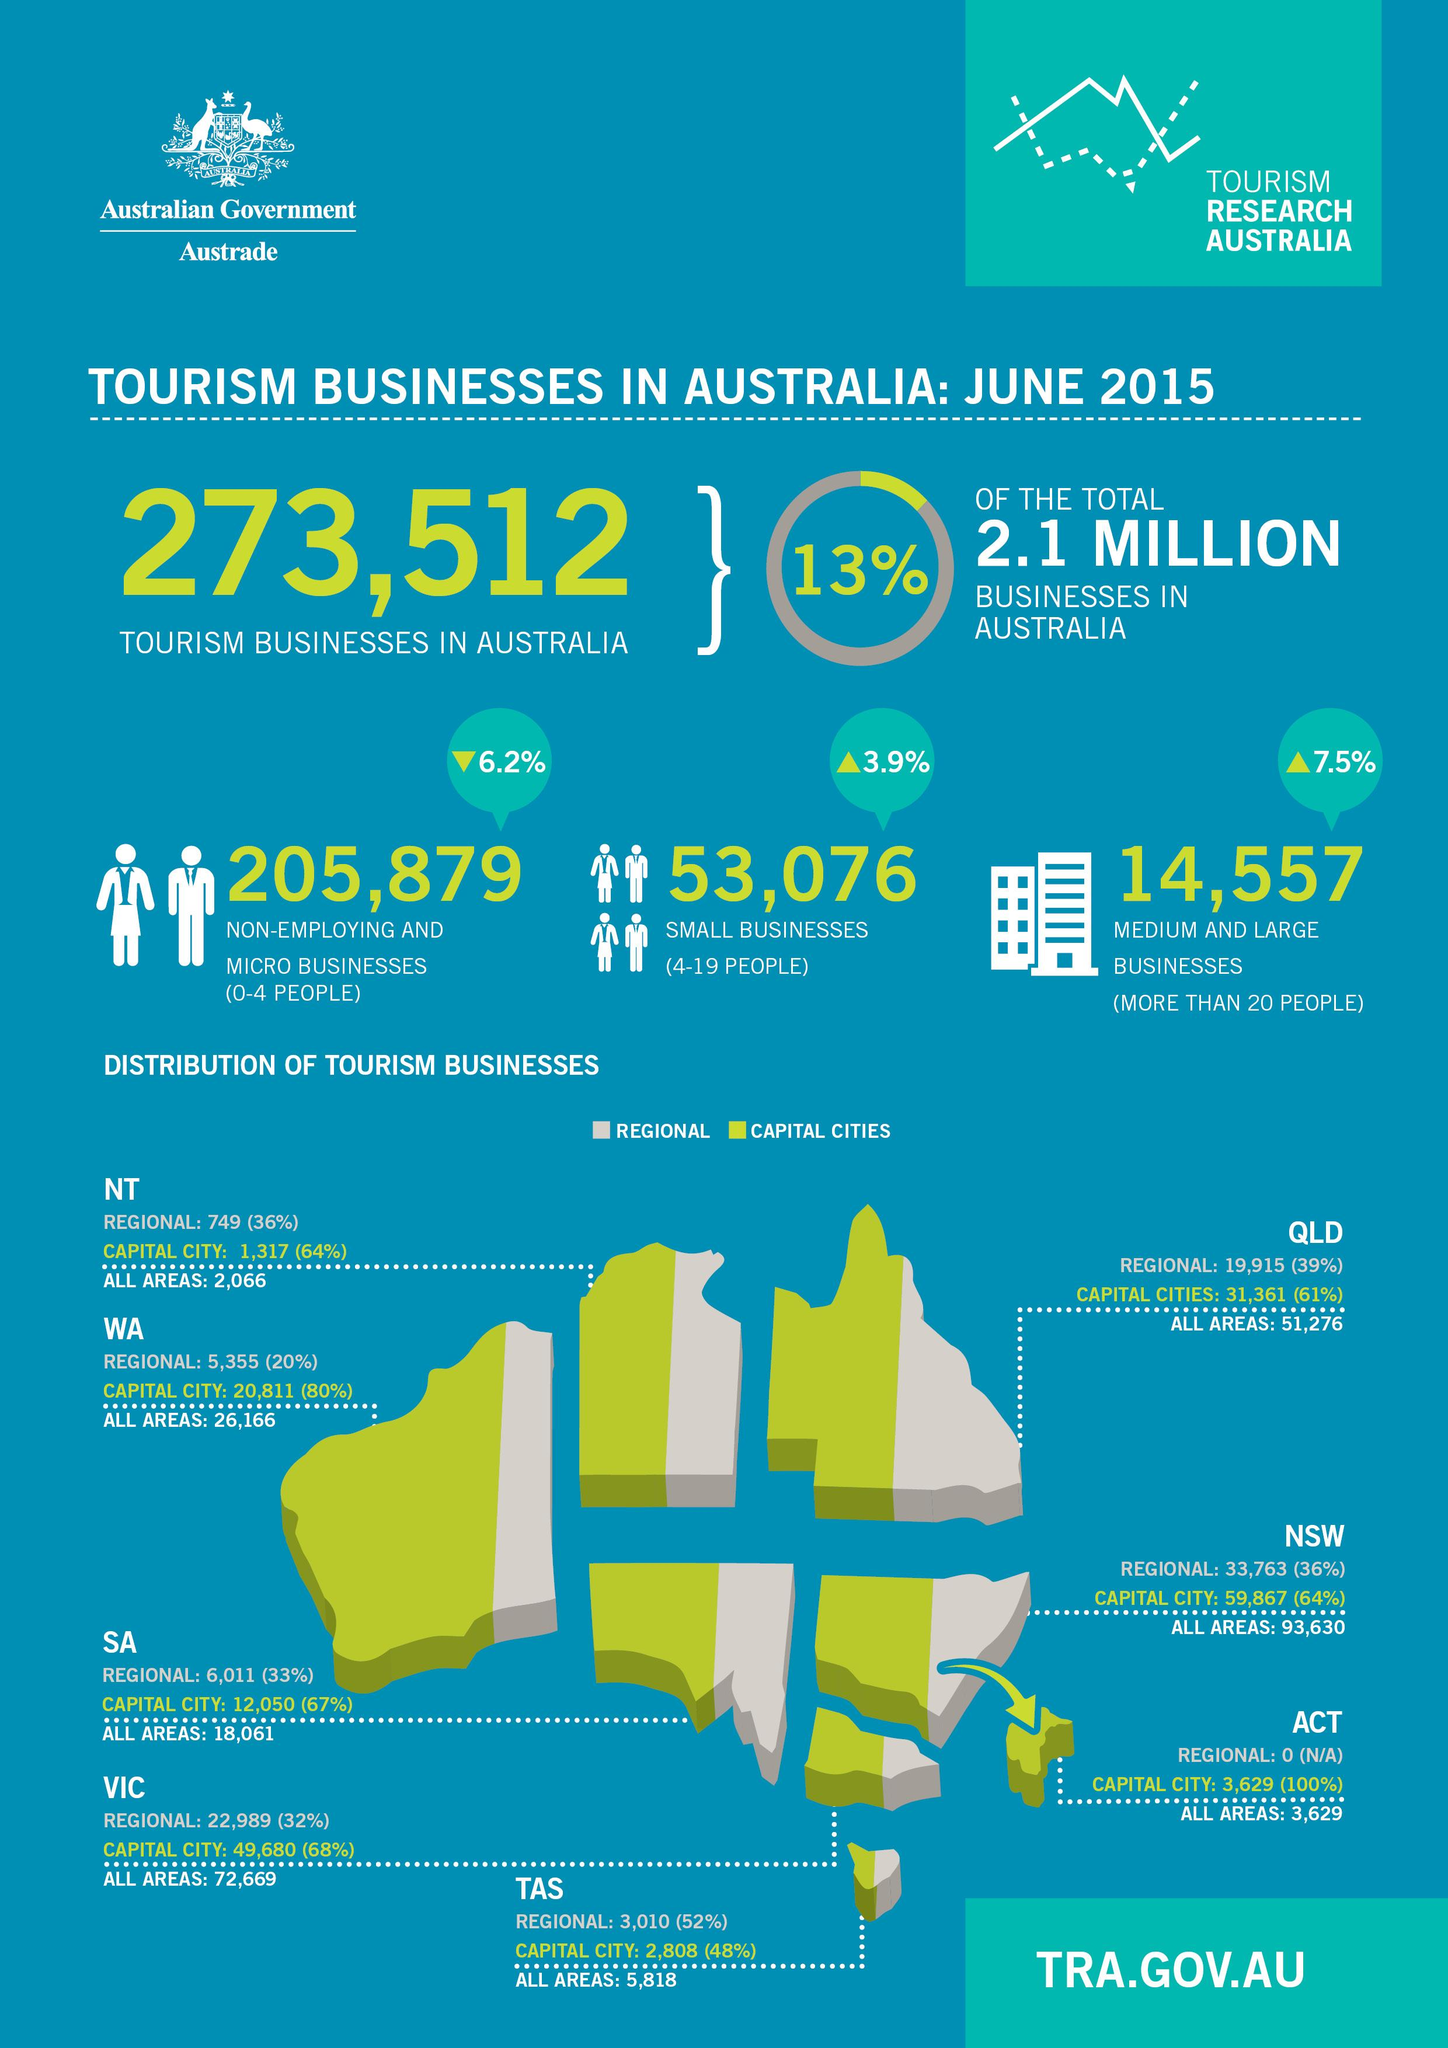Identify some key points in this picture. There are 14,557 medium and large tourism businesses in Australia. According to data, there are 205,879 non-employing and micro businesses in Australia. There are a significant number of businesses in Australia with more than 20 people employed that are doing medium and large business. There are 51,276 tourism businesses operating in various areas of Queensland. In the capital cities of Queensland, 61% of businesses are in the tourism industry. 